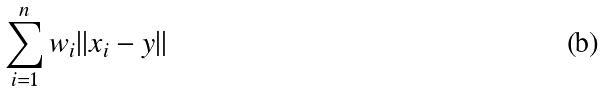Convert formula to latex. <formula><loc_0><loc_0><loc_500><loc_500>\sum _ { i = 1 } ^ { n } w _ { i } | | x _ { i } - y | |</formula> 